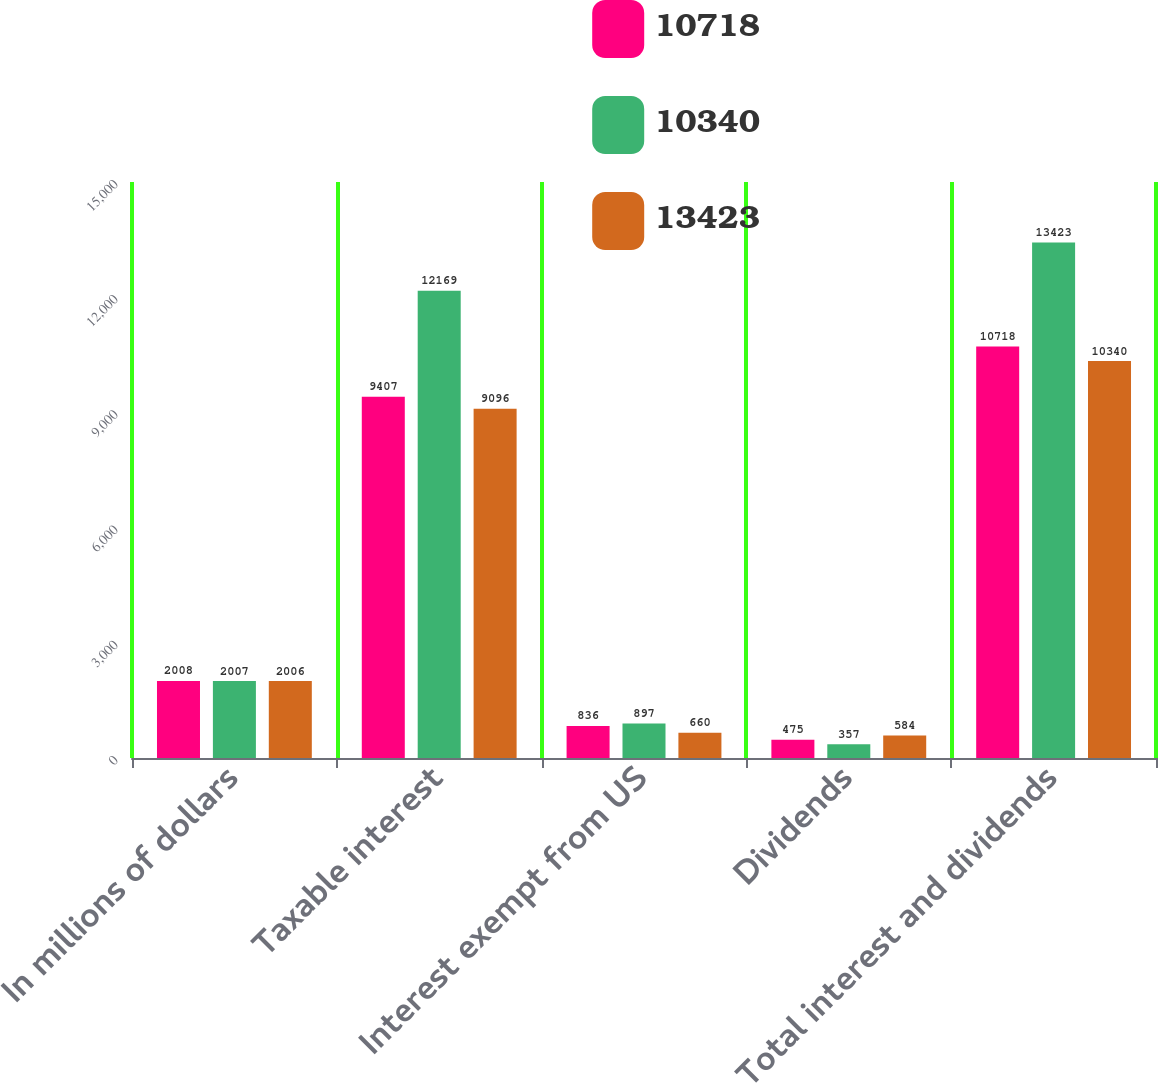Convert chart to OTSL. <chart><loc_0><loc_0><loc_500><loc_500><stacked_bar_chart><ecel><fcel>In millions of dollars<fcel>Taxable interest<fcel>Interest exempt from US<fcel>Dividends<fcel>Total interest and dividends<nl><fcel>10718<fcel>2008<fcel>9407<fcel>836<fcel>475<fcel>10718<nl><fcel>10340<fcel>2007<fcel>12169<fcel>897<fcel>357<fcel>13423<nl><fcel>13423<fcel>2006<fcel>9096<fcel>660<fcel>584<fcel>10340<nl></chart> 